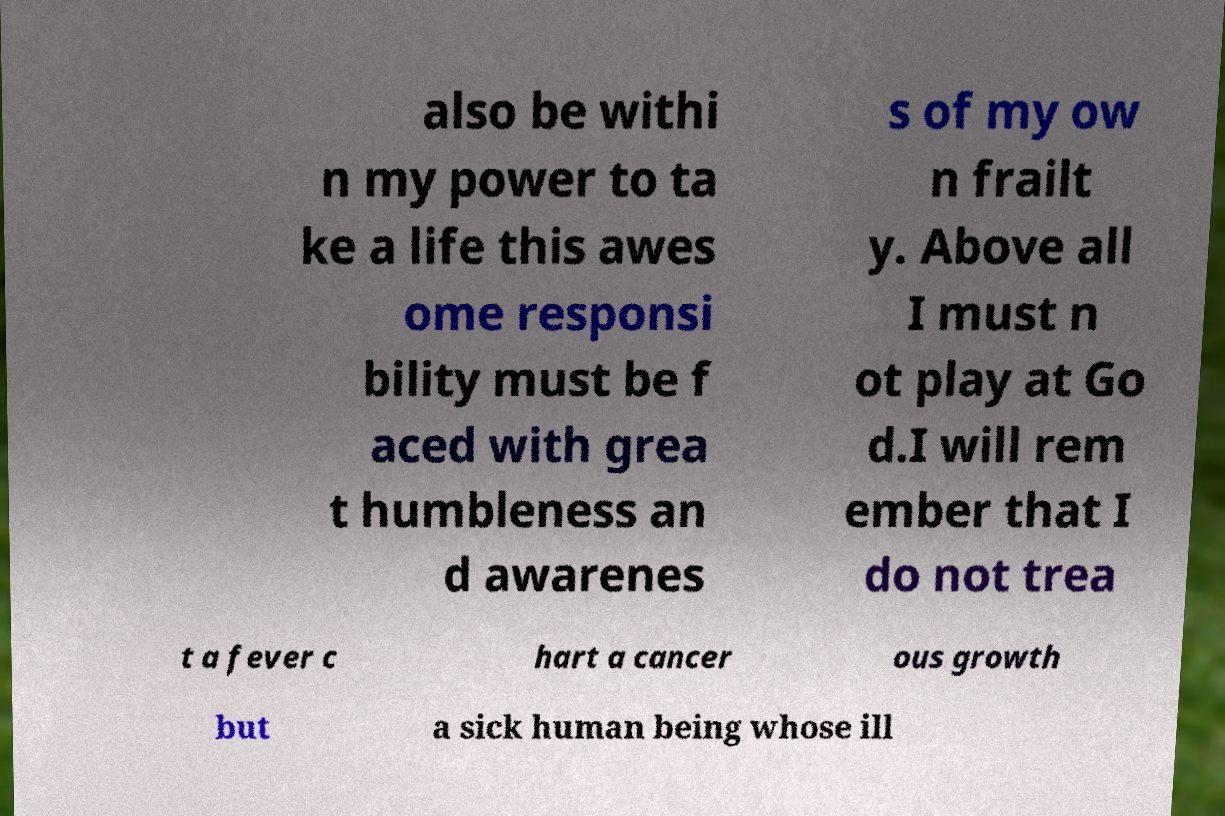Could you assist in decoding the text presented in this image and type it out clearly? also be withi n my power to ta ke a life this awes ome responsi bility must be f aced with grea t humbleness an d awarenes s of my ow n frailt y. Above all I must n ot play at Go d.I will rem ember that I do not trea t a fever c hart a cancer ous growth but a sick human being whose ill 